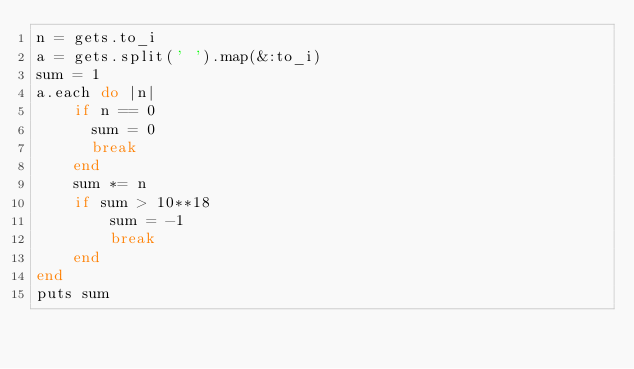Convert code to text. <code><loc_0><loc_0><loc_500><loc_500><_Ruby_>n = gets.to_i
a = gets.split(' ').map(&:to_i)
sum = 1
a.each do |n|
  	if n == 0
      sum = 0
      break
    end
    sum *= n
    if sum > 10**18
        sum = -1
        break
    end
end
puts sum</code> 